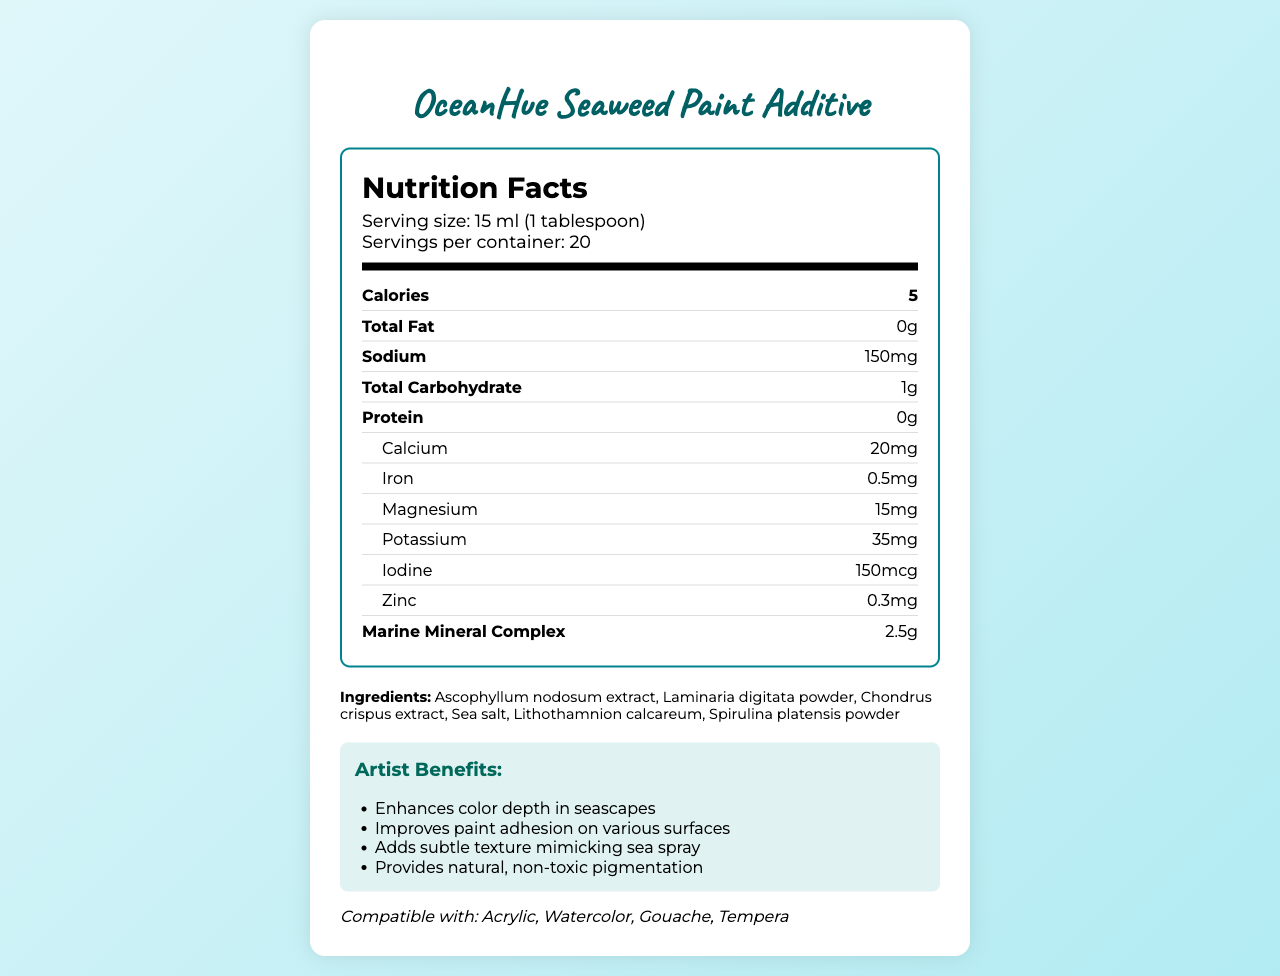what is the serving size of OceanHue Seaweed Paint Additive? The document states that the serving size is 15 ml, equivalent to 1 tablespoon.
Answer: 15 ml (1 tablespoon) how many servings are there in each container of OceanHue Seaweed Paint Additive? The document indicates that there are 20 servings per container.
Answer: 20 how many calories are in one serving of OceanHue Seaweed Paint Additive? The document shows that one serving contains 5 calories.
Answer: 5 what is the sodium content per serving? The nutrition facts indicate that there are 150 mg of sodium per serving.
Answer: 150 mg what minerals are included in OceanHue Seaweed Paint Additive? The document lists these minerals in the nutrient breakdown.
Answer: Calcium, Iron, Magnesium, Potassium, Iodine, Zinc which ingredients are used in OceanHue Seaweed Paint Additive? The ingredient list in the document includes these components.
Answer: Ascophyllum nodosum extract, Laminaria digitata powder, Chondrus crispus extract, Sea salt, Lithothamnion calcareum, Spirulina platensis powder what are the artist benefits of using OceanHue Seaweed Paint Additive? The artist benefits section lists these advantages.
Answer: Enhances color depth in seascapes, Improves paint adhesion on various surfaces, Adds subtle texture mimicking sea spray, Provides natural, non-toxic pigmentation is OceanHue Seaweed Paint Additive compatible with oil-based paints? (Yes/No) The document states that it is compatible with acrylic, watercolor, gouache, and tempera, but does not mention oil-based paints.
Answer: No what certifications does OceanHue Seaweed Paint Additive hold? The document mentions these three certifications.
Answer: Vegan, Cruelty-free, Non-toxic which nutrient is present in the smallest amount per serving? A. Magnesium B. Iodine C. Chlorophyll The document indicates that chlorophyll is present in the smallest amount per serving at 0.1 mg.
Answer: C. Chlorophyll how long is the shelf life of OceanHue Seaweed Paint Additive when stored properly? A. 12 months B. 18 months C. 24 months The document states that the shelf life is 24 months when stored properly.
Answer: C. 24 months what should you avoid to store OceanHue Seaweed Paint Additive properly? A. Warm temperatures B. Direct sunlight C. Humid environments D. All of the above The storage instructions advise keeping it in a cool, dry place away from direct sunlight, which implies avoiding warm temperatures and humid environments.
Answer: D. All of the above can the iodine content in OceanHue Seaweed Paint Additive be considered significant? The document states there are 150 mcg of iodine per serving, which is a significant amount.
Answer: Yes do you need to do anything special to the paint before adding the OceanHue Seaweed Paint Additive? The usage instructions specify mixing the additive thoroughly with water-based paints.
Answer: Mix thoroughly with water-based paints what is the purpose of adding marine minerals to the OceanHue Seaweed Paint Additive? The marine mineral complex aims to enhance texture and color, adding marine-themed elements to the paint.
Answer: Enhances paint texture and color, mimicking marine elements can children use this product without posing any risks? The document does not provide any specific information on the safety of the product for children.
Answer: Not enough information 